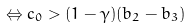Convert formula to latex. <formula><loc_0><loc_0><loc_500><loc_500>\Leftrightarrow c _ { 0 } > ( 1 - \gamma ) ( b _ { 2 } - b _ { 3 } )</formula> 